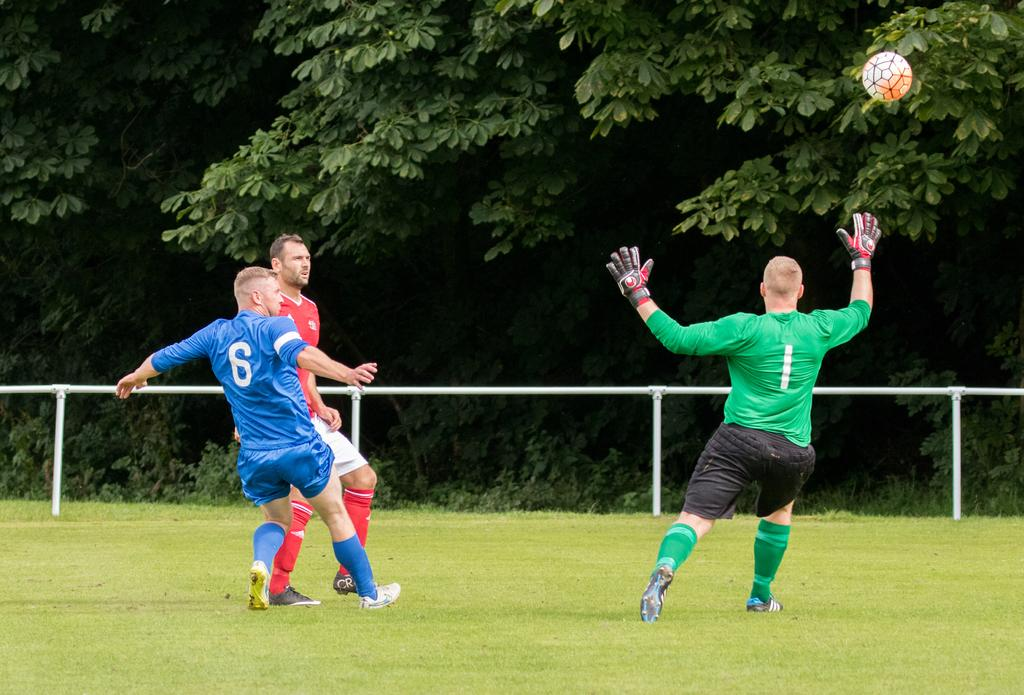What are the people in the image doing? The people in the image are playing in the center. What can be seen in the background of the image? There are trees and a fence in the background. What object is visible in the image that might be used for a game? A ball is visible in the image. What type of surface is at the bottom of the image? There is ground at the bottom of the image. What type of music is the band playing in the background of the image? There is no band present in the background of the image. What is the person carrying in the image? There is no person carrying a bag in the image. 